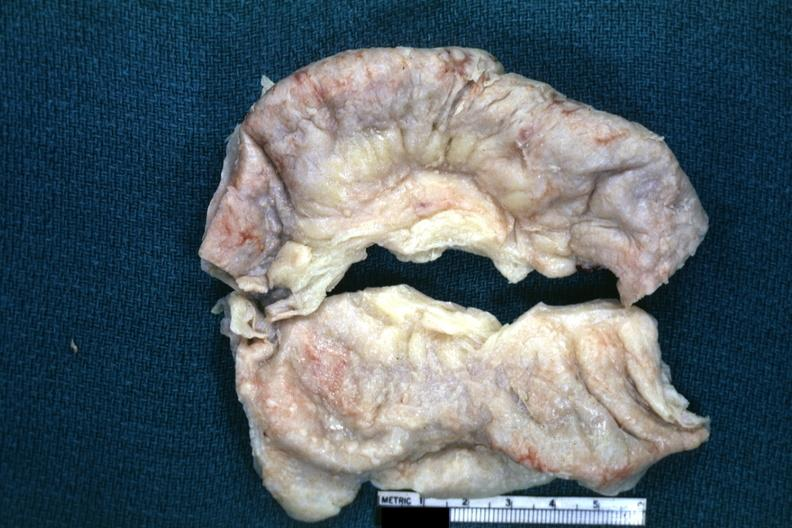what does this image show?
Answer the question using a single word or phrase. Fixed tissue typical appearance of tuberculous peritonitis except for color being off a bit 